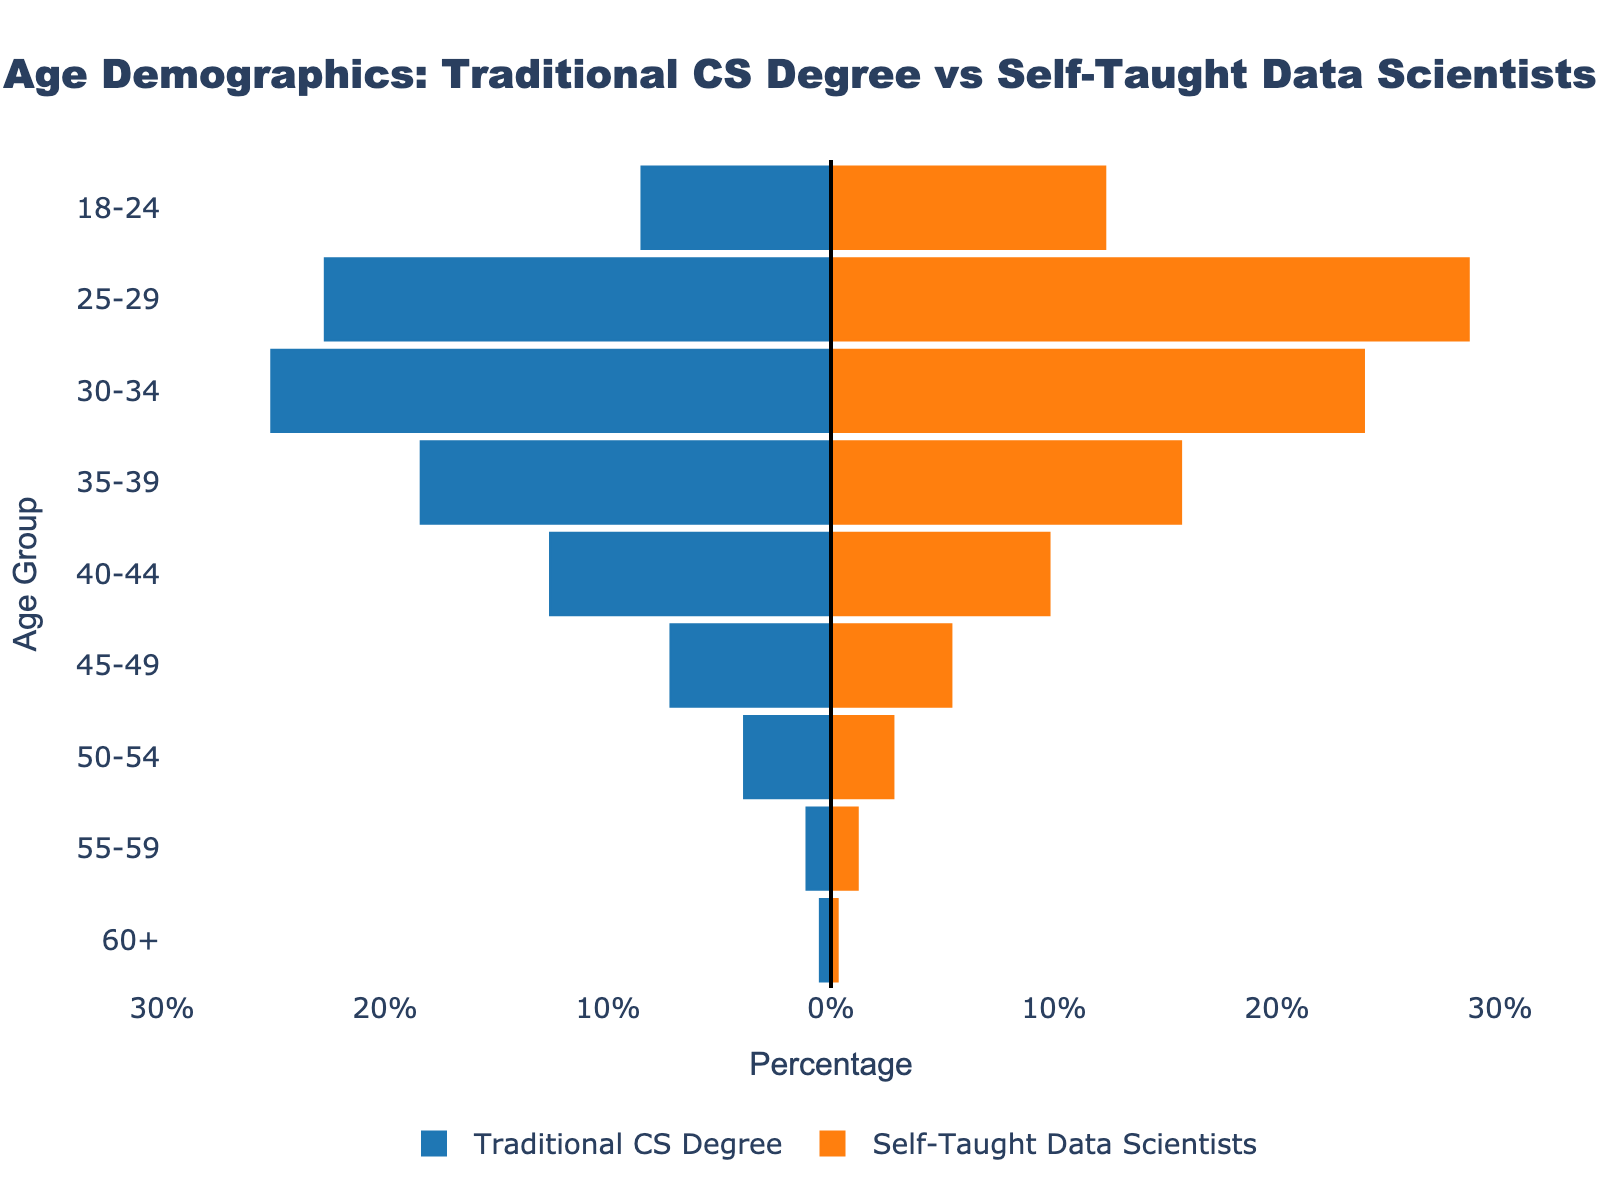Which age group has the highest percentage of self-taught data scientists? Examine the Self-Taught Data Scientists section and identify the age group with the highest bar. The percentage is highest for the 25-29 age group.
Answer: 25-29 What is the difference in percentage between traditional CS degree holders and self-taught data scientists in the 30-34 age group? Look at the 30-34 age group's bars and subtract the percentage for self-taught data scientists (23.9) from traditional CS degree holders (25.1). The calculation is 25.1 - 23.9.
Answer: 1.2 Which age group has a larger percentage of traditional CS degree holders compared to self-taught data scientists? Compare the heights of the bars for each age group and identify where traditional CS degree holders have a taller bar. This is the case for the 30-34, 35-39, 40-44, 45-49, 50-54, 55-59, and 60+ age groups.
Answer: Multiple age groups (30-34, 35-39, 40-44, 45-49, 50-54, 55-59, 60+) What is the total percentage of self-taught data scientists in the 18-24, 25-29, and 30-34 age groups combined? Add the percentages of self-taught data scientists for the 18-24 (12.3), 25-29 (28.6), and 30-34 (23.9) age groups. The calculation is 12.3 + 28.6 + 23.9.
Answer: 64.8 How do the percentages of traditional CS degree holders and self-taught data scientists compare in the 45-49 age group? Look at the bars for the 45-49 age group and compare the heights. Traditional CS degree holders have a taller bar with 7.2%, whereas self-taught data scientists have 5.4%.
Answer: Traditional CS Degree > Self-Taught Data Scientists What is the sum of the percentages for traditional CS degree holders aged 40 and above? Add the percentages for traditional CS degree holders in age groups 40-44, 45-49, 50-54, 55-59, and 60+.
- 40-44: 12.6
- 45-49: 7.2
- 50-54: 3.9
- 55-59: 1.1
- 60+: 0.5
The calculation is 12.6 + 7.2 + 3.9 + 1.1 + 0.5.
Answer: 25.3 